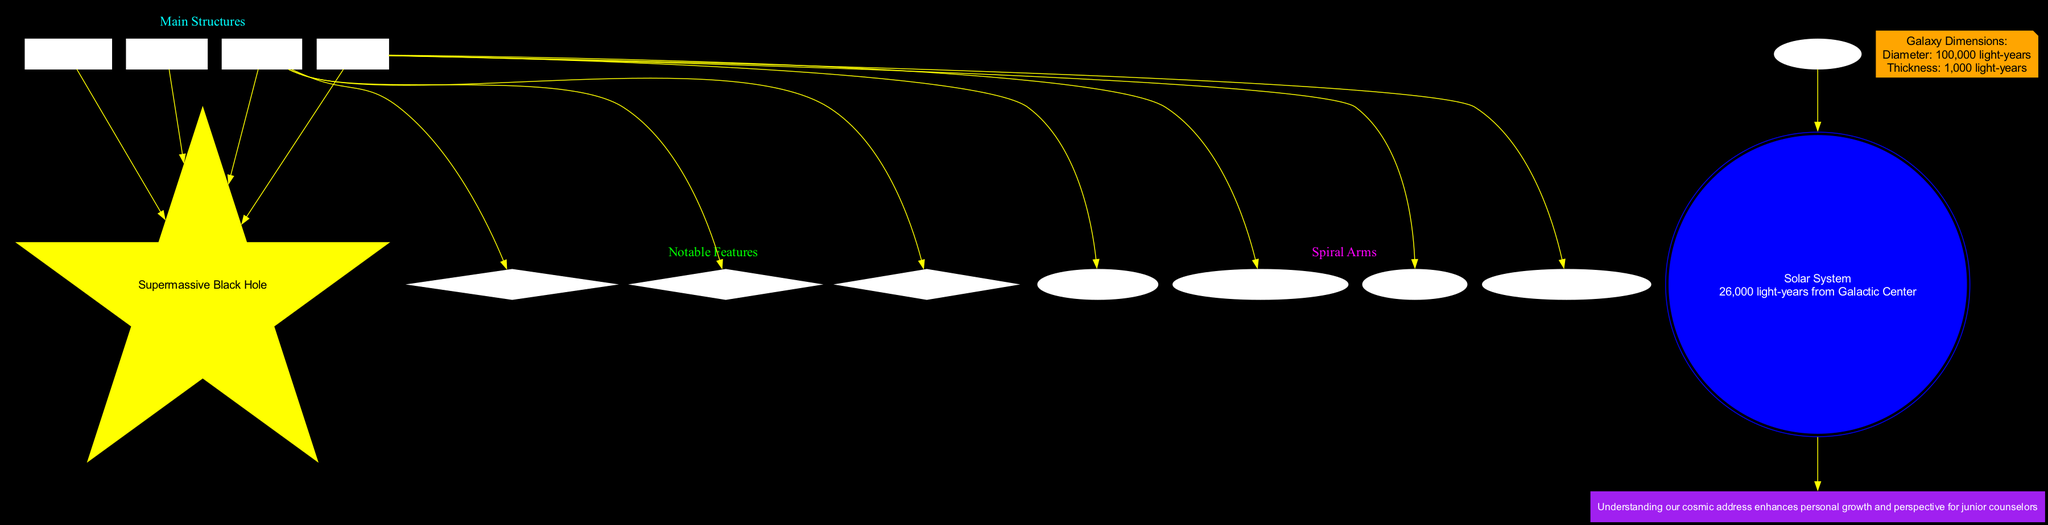What is at the center of the Milky Way galaxy? The diagram clearly labels the center node as "Supermassive Black Hole," which is the focal point of the galaxy's structure.
Answer: Supermassive Black Hole How far is the Solar System from the Galactic Center? The Solar System node indicates its distance from the Galactic Center as "26,000 light-years," providing a specific measurement listed directly on the diagram.
Answer: 26,000 light-years How many spiral arms are identified in the diagram? The diagram lists four spiral arms: Perseus Arm, Orion Arm, Sagittarius Arm, and Scutum-Centaurus Arm. Counting them gives a total of four.
Answer: 4 What feature is directly linked to the Galactic Disk? The notable feature "Interstellar Medium" is connected to the Galactic Disk in the diagram, showing a direct relationship established with an edge.
Answer: Interstellar Medium Which color represents the main structures in the diagram? The main structures are presented in a cyan font color in the label of the subgraph, which is specified in the diagram’s attributes.
Answer: Cyan What relationship exists between the Solar System and the counseling perspective? The diagram shows that the Solar System node has an edge leading to the counseling perspective node, indicating that understanding our cosmic address impacts personal growth and perspective.
Answer: Understanding Which arm is also known as the Local Arm? The diagram specifies the "Orion Arm" as the Local Arm within the list of spiral arms, directly calling out its alternative name.
Answer: Orion Arm (Local Arm) What is the thickness of the galaxy? The galaxy's dimensions are mentioned, and the thickness is stated as "1,000 light-years," which is explicitly included in the dimensions node.
Answer: 1,000 light-years What type of node represents the Solar System? The Solar System is represented as a "doublecircle" node in blue color, providing a distinct visual identity associated with this specific cosmic location.
Answer: Doublecircle 